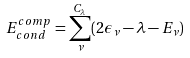<formula> <loc_0><loc_0><loc_500><loc_500>E _ { c o n d } ^ { c o m p } = \sum _ { \nu } ^ { C _ { \lambda } } ( 2 \epsilon _ { \nu } - \lambda - E _ { \nu } )</formula> 